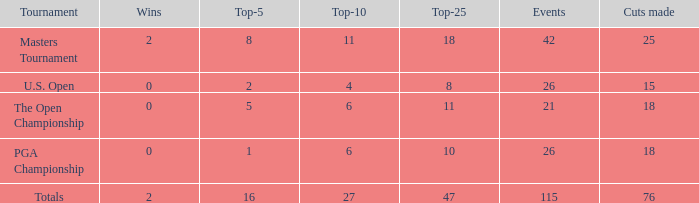When the wins are less than 0 and the Top-5 1 what is the average cuts? None. 